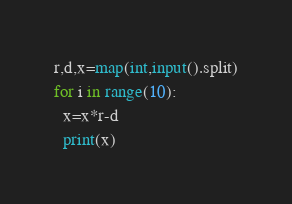Convert code to text. <code><loc_0><loc_0><loc_500><loc_500><_Python_>r,d,x=map(int,input().split)
for i in range(10):
  x=x*r-d
  print(x)
</code> 